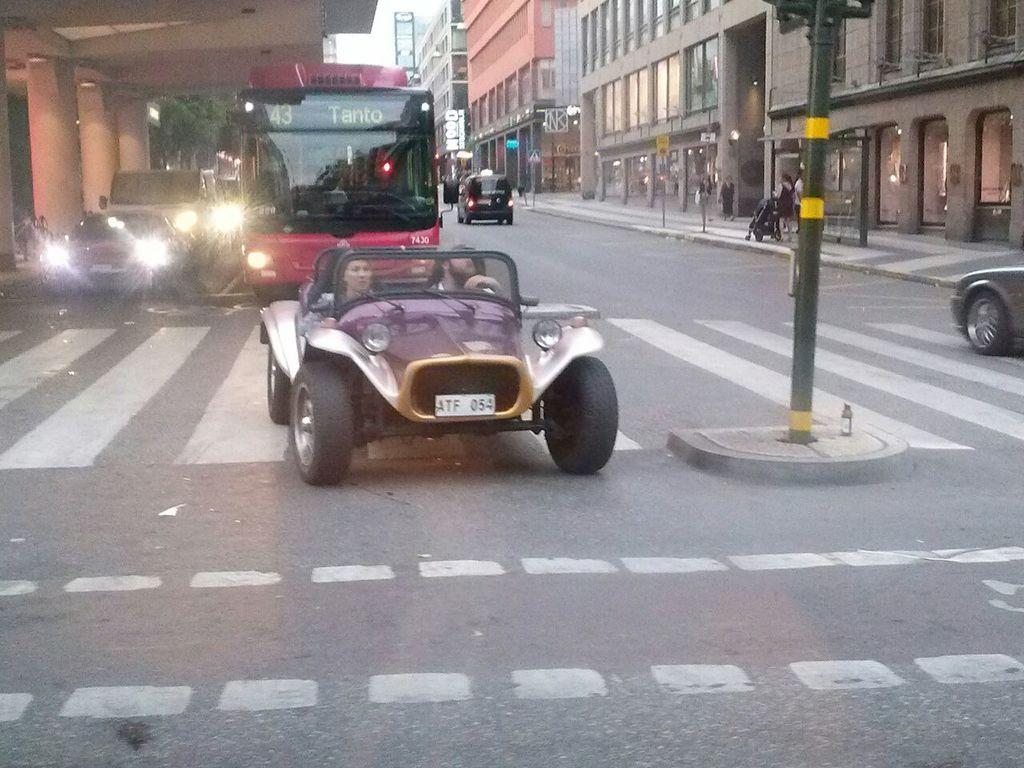What can be seen on the road in the image? There are many vehicles on the road in the image. What is the primary feature of the image? The image shows a road. What type of markings are present on the road? There are white lines on the road. What else is visible in the image besides the road? There are many buildings, a pole, and a tree in the image. What part of the natural environment is visible in the image? The sky is visible in the image. What type of bag is hanging from the tree in the image? There is no bag hanging from the tree in the image; only a tree is present. What effect does the regret have on the vehicles in the image? There is no mention of regret in the image, so it cannot have any effect on the vehicles. 